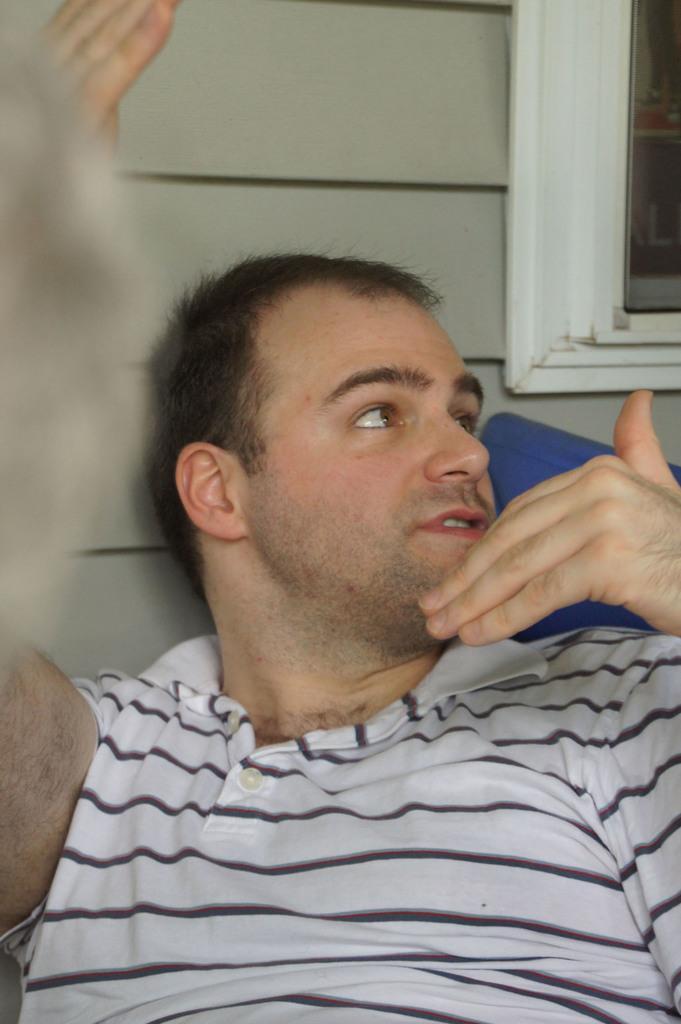Describe this image in one or two sentences. There is a person sitting on a chair and speaking. In the background, there is a window near wall. 